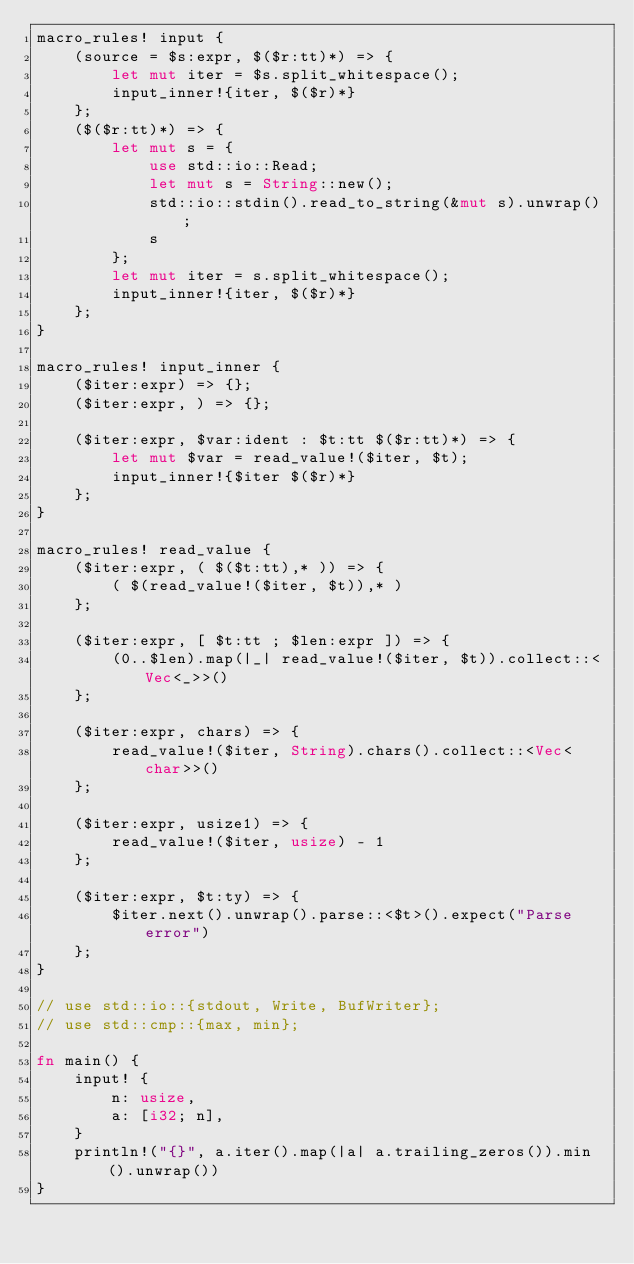<code> <loc_0><loc_0><loc_500><loc_500><_Rust_>macro_rules! input {
    (source = $s:expr, $($r:tt)*) => {
        let mut iter = $s.split_whitespace();
        input_inner!{iter, $($r)*}
    };
    ($($r:tt)*) => {
        let mut s = {
            use std::io::Read;
            let mut s = String::new();
            std::io::stdin().read_to_string(&mut s).unwrap();
            s
        };
        let mut iter = s.split_whitespace();
        input_inner!{iter, $($r)*}
    };
}

macro_rules! input_inner {
    ($iter:expr) => {};
    ($iter:expr, ) => {};

    ($iter:expr, $var:ident : $t:tt $($r:tt)*) => {
        let mut $var = read_value!($iter, $t);
        input_inner!{$iter $($r)*}
    };
}

macro_rules! read_value {
    ($iter:expr, ( $($t:tt),* )) => {
        ( $(read_value!($iter, $t)),* )
    };

    ($iter:expr, [ $t:tt ; $len:expr ]) => {
        (0..$len).map(|_| read_value!($iter, $t)).collect::<Vec<_>>()
    };

    ($iter:expr, chars) => {
        read_value!($iter, String).chars().collect::<Vec<char>>()
    };

    ($iter:expr, usize1) => {
        read_value!($iter, usize) - 1
    };

    ($iter:expr, $t:ty) => {
        $iter.next().unwrap().parse::<$t>().expect("Parse error")
    };
}

// use std::io::{stdout, Write, BufWriter};
// use std::cmp::{max, min};

fn main() {
    input! {
        n: usize,
        a: [i32; n],
    }
    println!("{}", a.iter().map(|a| a.trailing_zeros()).min().unwrap())
}
</code> 